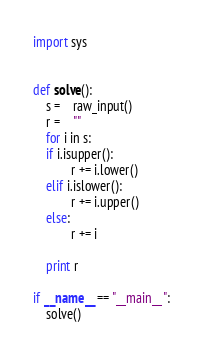<code> <loc_0><loc_0><loc_500><loc_500><_Python_>import sys


def solve():
    s =	raw_input()
    r =	""
    for i in s:
	if i.isupper():
            r += i.lower()
	elif i.islower():
            r += i.upper()
	else:
            r += i

    print r

if __name__ == "__main__":
    solve()</code> 